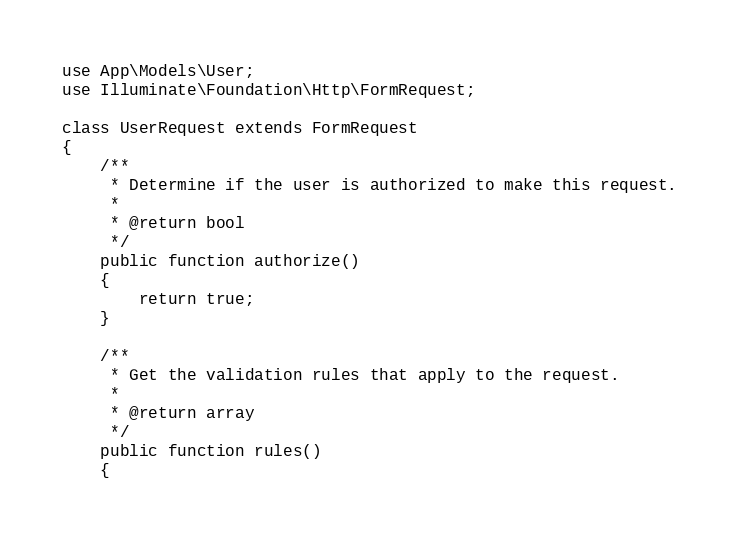<code> <loc_0><loc_0><loc_500><loc_500><_PHP_>use App\Models\User;
use Illuminate\Foundation\Http\FormRequest;

class UserRequest extends FormRequest
{
    /**
     * Determine if the user is authorized to make this request.
     *
     * @return bool
     */
    public function authorize()
    {
        return true;
    }

    /**
     * Get the validation rules that apply to the request.
     *
     * @return array
     */
    public function rules()
    {</code> 